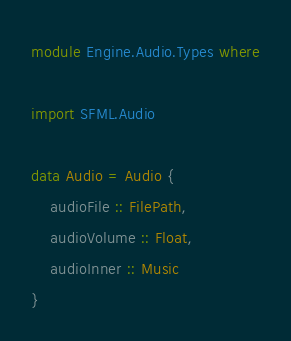Convert code to text. <code><loc_0><loc_0><loc_500><loc_500><_Haskell_>module Engine.Audio.Types where

import SFML.Audio

data Audio = Audio {
    audioFile :: FilePath,
    audioVolume :: Float,
    audioInner :: Music
}
</code> 